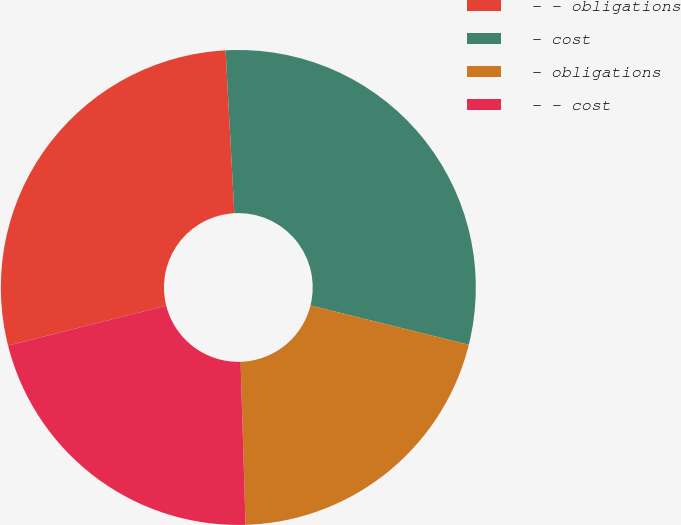<chart> <loc_0><loc_0><loc_500><loc_500><pie_chart><fcel>- - obligations<fcel>- cost<fcel>- obligations<fcel>- - cost<nl><fcel>28.08%<fcel>29.73%<fcel>20.64%<fcel>21.55%<nl></chart> 